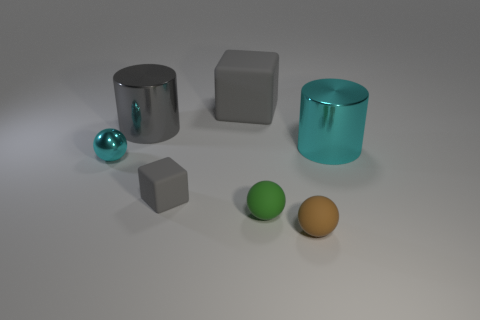There is another matte object that is the same color as the big rubber object; what is its size?
Offer a very short reply. Small. There is a rubber cube behind the cyan metallic sphere; how big is it?
Your answer should be compact. Large. Are there fewer tiny shiny things behind the tiny cyan shiny sphere than big metal things that are to the right of the gray metal cylinder?
Ensure brevity in your answer.  Yes. The shiny sphere has what color?
Offer a very short reply. Cyan. Is there another cube of the same color as the tiny cube?
Offer a terse response. Yes. There is a big thing behind the big shiny thing that is to the left of the cyan object that is on the right side of the green ball; what shape is it?
Make the answer very short. Cube. There is a cube behind the metallic sphere; what is its material?
Provide a short and direct response. Rubber. What is the size of the matte object on the left side of the large thing behind the metal object that is behind the cyan shiny cylinder?
Your response must be concise. Small. Does the cyan cylinder have the same size as the gray cube in front of the small cyan thing?
Provide a succinct answer. No. The sphere that is left of the big rubber object is what color?
Provide a succinct answer. Cyan. 